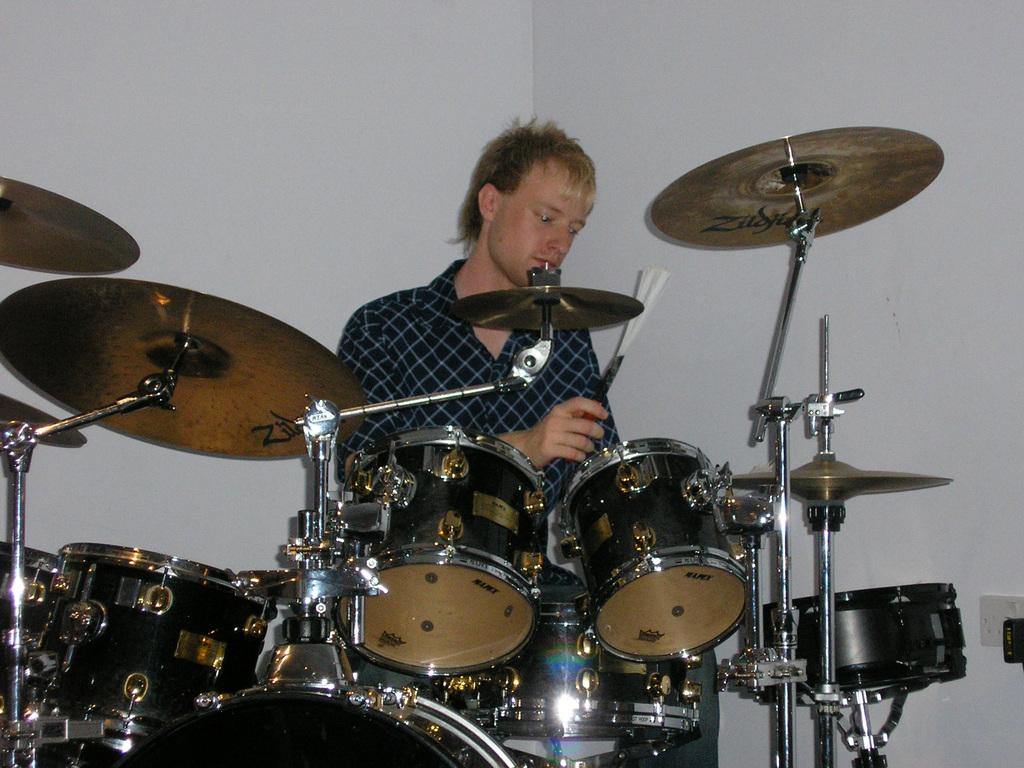What is the main subject of the image? There is a person in the image. What is the person doing in the image? The person is playing drums. What type of headwear is the person wearing while playing the drums in the image? There is no headwear visible on the person in the image. What song is the person playing on the drums in the image? The image does not provide information about the specific song being played on the drums. 